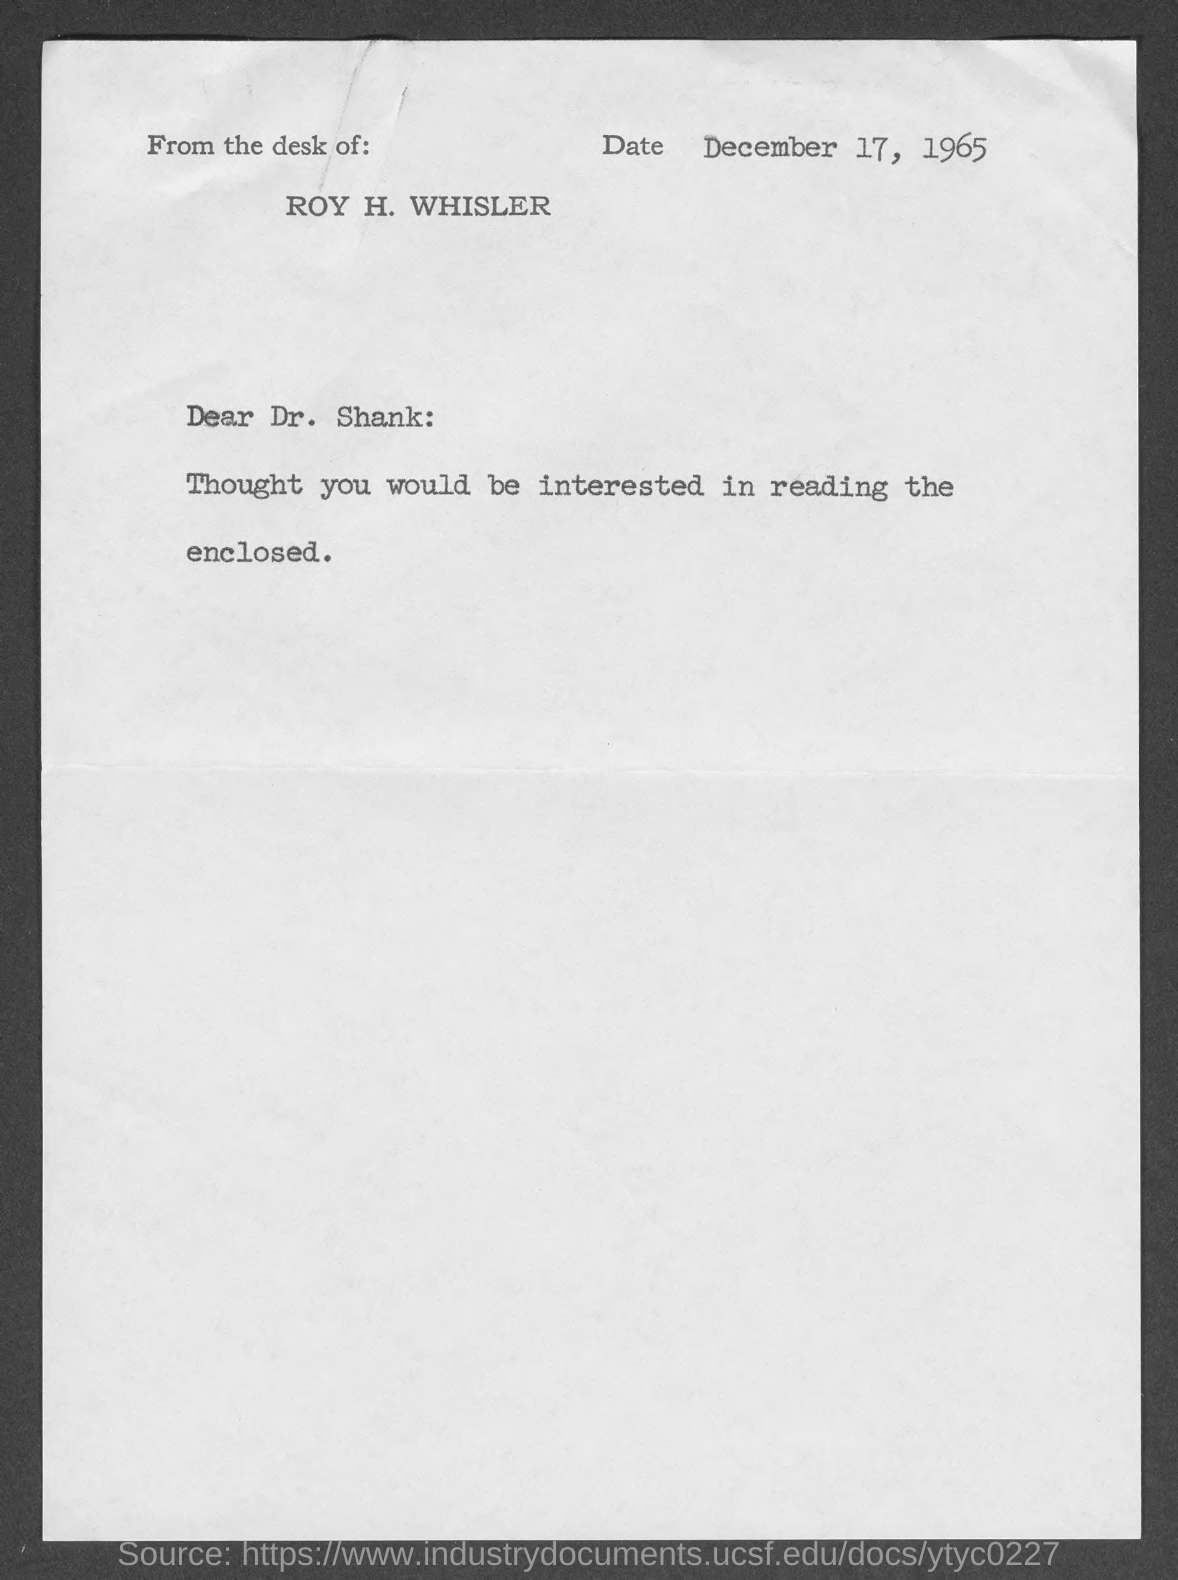What is the date?
Provide a succinct answer. December 17, 1965. What is the salutation of this letter?
Give a very brief answer. Dear. 